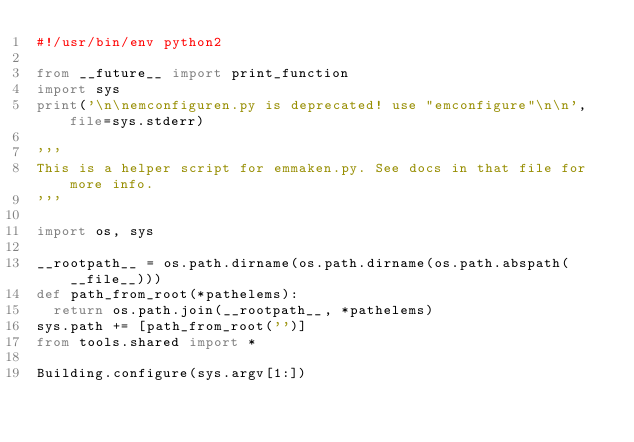<code> <loc_0><loc_0><loc_500><loc_500><_Python_>#!/usr/bin/env python2

from __future__ import print_function
import sys
print('\n\nemconfiguren.py is deprecated! use "emconfigure"\n\n', file=sys.stderr)

'''
This is a helper script for emmaken.py. See docs in that file for more info.
'''

import os, sys

__rootpath__ = os.path.dirname(os.path.dirname(os.path.abspath(__file__)))
def path_from_root(*pathelems):
  return os.path.join(__rootpath__, *pathelems)
sys.path += [path_from_root('')]
from tools.shared import *

Building.configure(sys.argv[1:])

</code> 